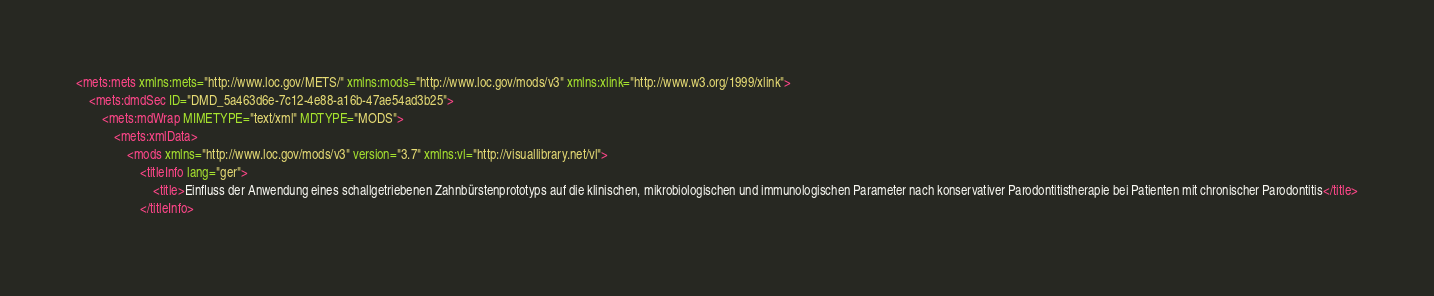Convert code to text. <code><loc_0><loc_0><loc_500><loc_500><_XML_><mets:mets xmlns:mets="http://www.loc.gov/METS/" xmlns:mods="http://www.loc.gov/mods/v3" xmlns:xlink="http://www.w3.org/1999/xlink">
    <mets:dmdSec ID="DMD_5a463d6e-7c12-4e88-a16b-47ae54ad3b25">
        <mets:mdWrap MIMETYPE="text/xml" MDTYPE="MODS">
            <mets:xmlData>
                <mods xmlns="http://www.loc.gov/mods/v3" version="3.7" xmlns:vl="http://visuallibrary.net/vl">
                    <titleInfo lang="ger">
                        <title>Einfluss der Anwendung eines schallgetriebenen Zahnbürstenprototyps auf die klinischen, mikrobiologischen und immunologischen Parameter nach konservativer Parodontitistherapie bei Patienten mit chronischer Parodontitis</title>
                    </titleInfo></code> 